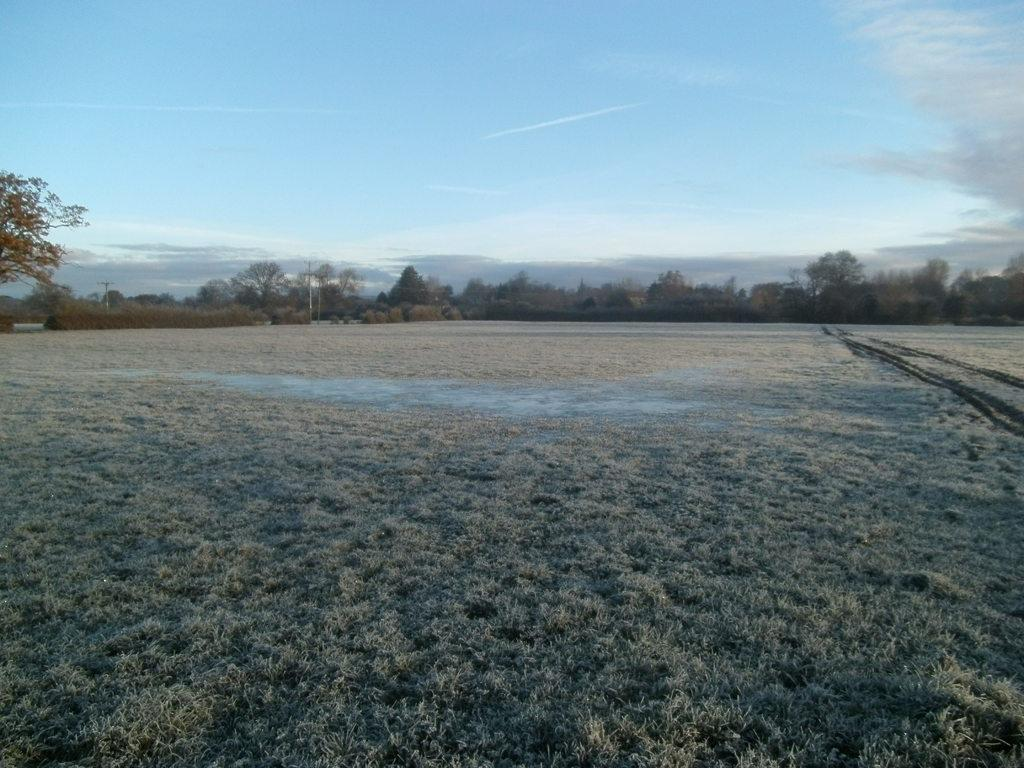What is the ground surface like in the image? The ground in the image is covered with dry grass. What can be seen in the distance in the image? There are many trees visible in the background. What is the condition of the sky in the image? The sky is clear in the image. How many thumbs can be seen in the image? There are no thumbs present in the image. 